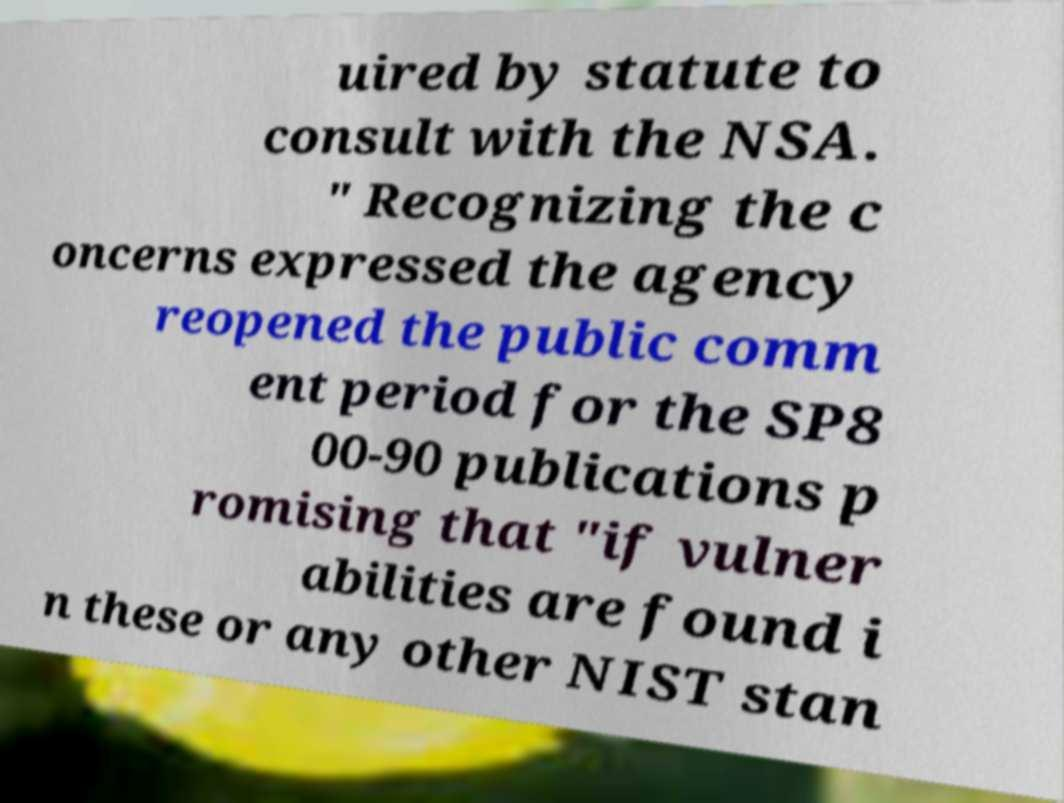Could you extract and type out the text from this image? uired by statute to consult with the NSA. " Recognizing the c oncerns expressed the agency reopened the public comm ent period for the SP8 00-90 publications p romising that "if vulner abilities are found i n these or any other NIST stan 